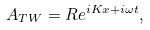Convert formula to latex. <formula><loc_0><loc_0><loc_500><loc_500>A _ { T W } = R e ^ { i K x + i \omega t } ,</formula> 